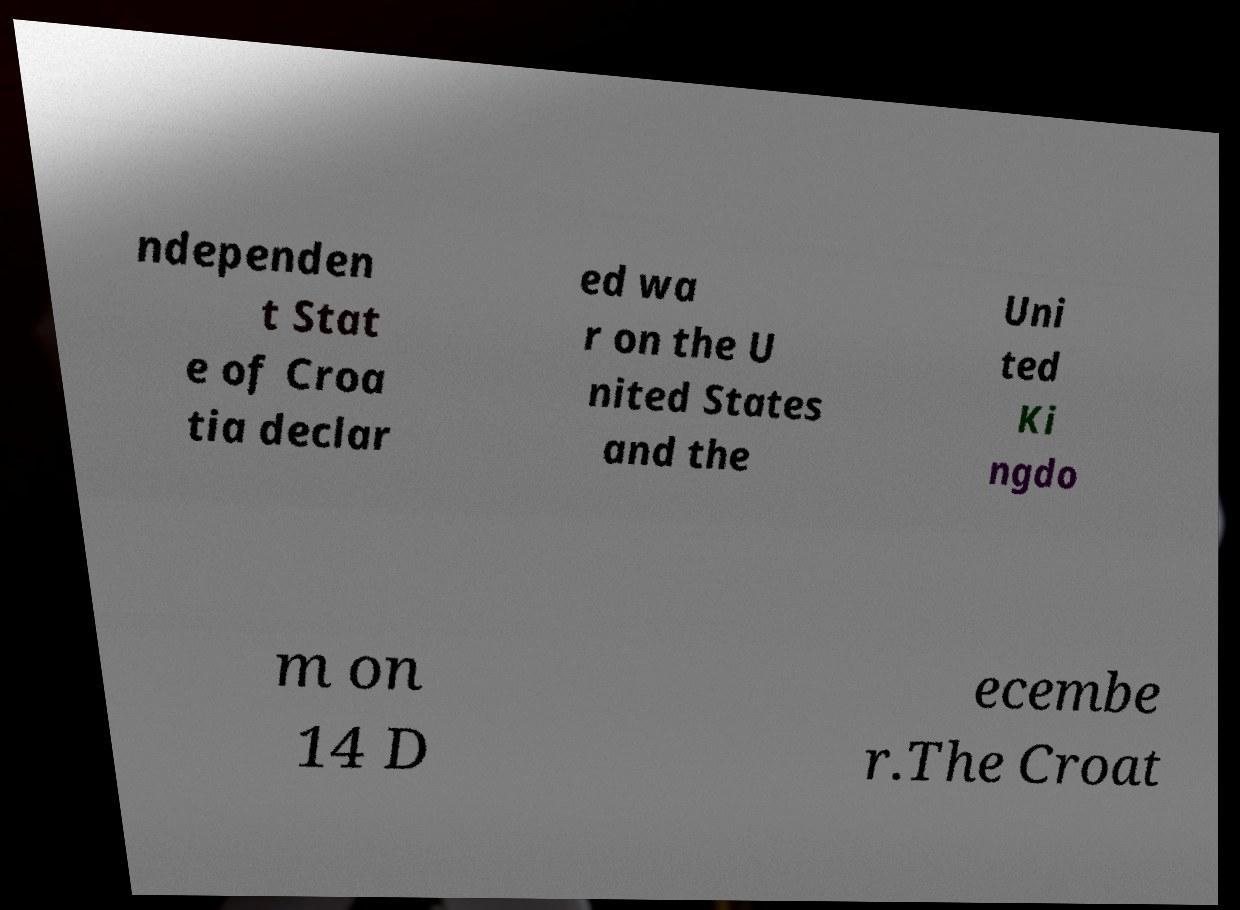Could you extract and type out the text from this image? ndependen t Stat e of Croa tia declar ed wa r on the U nited States and the Uni ted Ki ngdo m on 14 D ecembe r.The Croat 